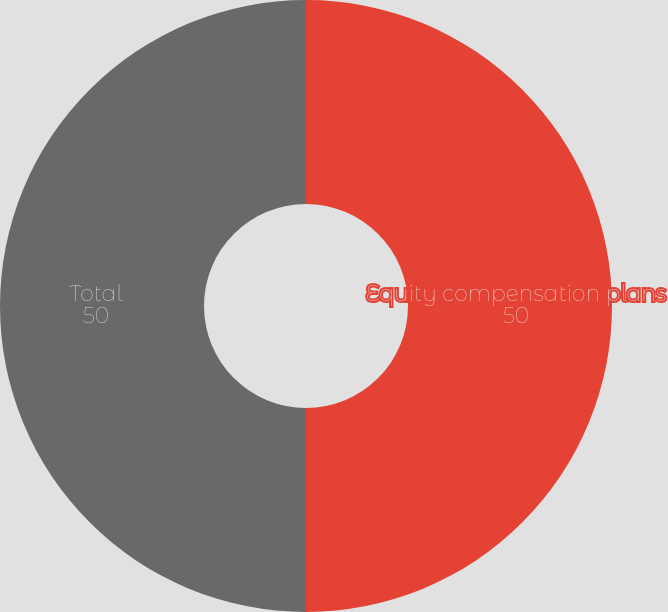Convert chart. <chart><loc_0><loc_0><loc_500><loc_500><pie_chart><fcel>Equity compensation plans<fcel>Total<nl><fcel>50.0%<fcel>50.0%<nl></chart> 